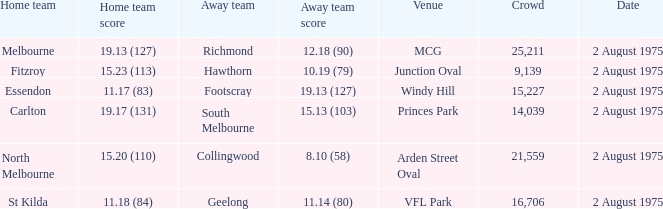Could you parse the entire table as a dict? {'header': ['Home team', 'Home team score', 'Away team', 'Away team score', 'Venue', 'Crowd', 'Date'], 'rows': [['Melbourne', '19.13 (127)', 'Richmond', '12.18 (90)', 'MCG', '25,211', '2 August 1975'], ['Fitzroy', '15.23 (113)', 'Hawthorn', '10.19 (79)', 'Junction Oval', '9,139', '2 August 1975'], ['Essendon', '11.17 (83)', 'Footscray', '19.13 (127)', 'Windy Hill', '15,227', '2 August 1975'], ['Carlton', '19.17 (131)', 'South Melbourne', '15.13 (103)', 'Princes Park', '14,039', '2 August 1975'], ['North Melbourne', '15.20 (110)', 'Collingwood', '8.10 (58)', 'Arden Street Oval', '21,559', '2 August 1975'], ['St Kilda', '11.18 (84)', 'Geelong', '11.14 (80)', 'VFL Park', '16,706', '2 August 1975']]} When did a game take place where the away team achieved 1 2 August 1975. 